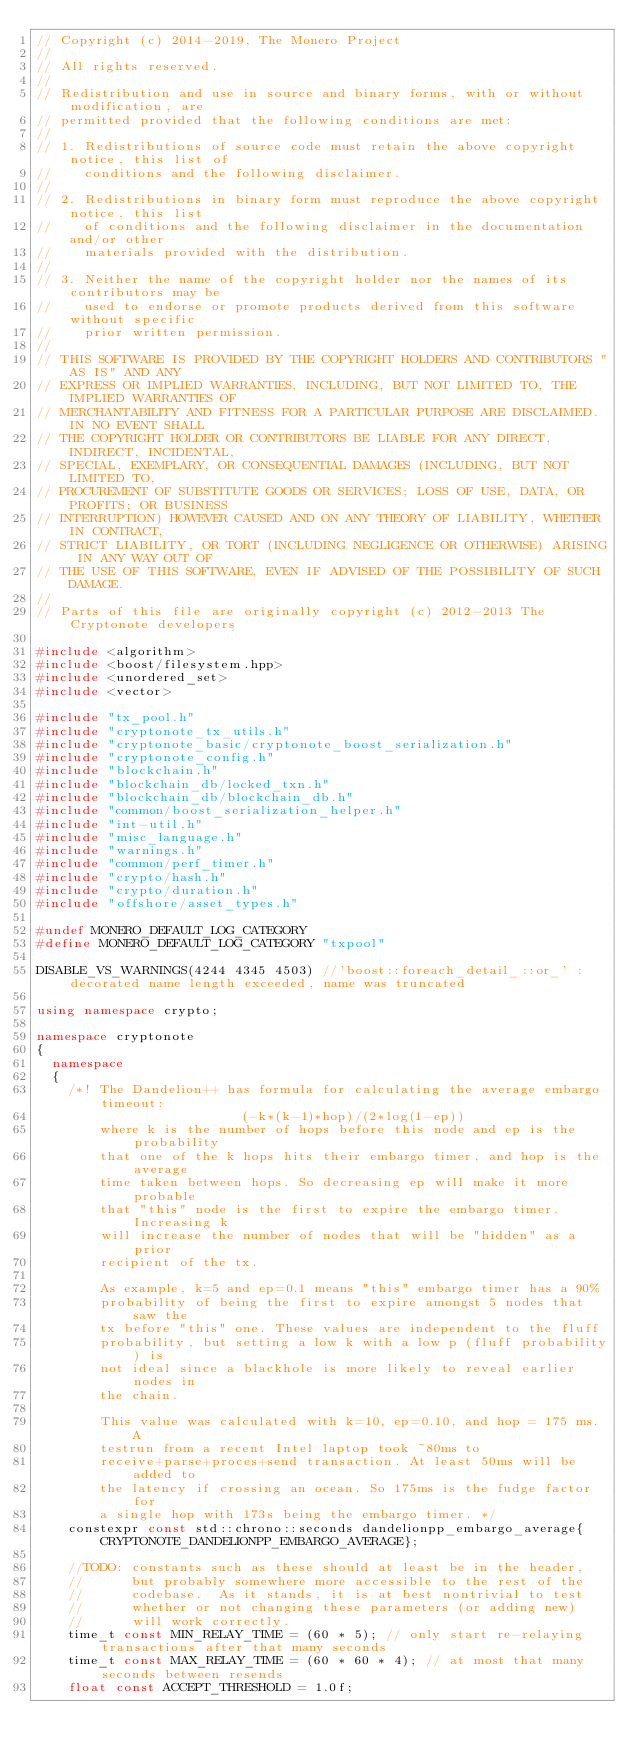Convert code to text. <code><loc_0><loc_0><loc_500><loc_500><_C++_>// Copyright (c) 2014-2019, The Monero Project
//
// All rights reserved.
//
// Redistribution and use in source and binary forms, with or without modification, are
// permitted provided that the following conditions are met:
//
// 1. Redistributions of source code must retain the above copyright notice, this list of
//    conditions and the following disclaimer.
//
// 2. Redistributions in binary form must reproduce the above copyright notice, this list
//    of conditions and the following disclaimer in the documentation and/or other
//    materials provided with the distribution.
//
// 3. Neither the name of the copyright holder nor the names of its contributors may be
//    used to endorse or promote products derived from this software without specific
//    prior written permission.
//
// THIS SOFTWARE IS PROVIDED BY THE COPYRIGHT HOLDERS AND CONTRIBUTORS "AS IS" AND ANY
// EXPRESS OR IMPLIED WARRANTIES, INCLUDING, BUT NOT LIMITED TO, THE IMPLIED WARRANTIES OF
// MERCHANTABILITY AND FITNESS FOR A PARTICULAR PURPOSE ARE DISCLAIMED. IN NO EVENT SHALL
// THE COPYRIGHT HOLDER OR CONTRIBUTORS BE LIABLE FOR ANY DIRECT, INDIRECT, INCIDENTAL,
// SPECIAL, EXEMPLARY, OR CONSEQUENTIAL DAMAGES (INCLUDING, BUT NOT LIMITED TO,
// PROCUREMENT OF SUBSTITUTE GOODS OR SERVICES; LOSS OF USE, DATA, OR PROFITS; OR BUSINESS
// INTERRUPTION) HOWEVER CAUSED AND ON ANY THEORY OF LIABILITY, WHETHER IN CONTRACT,
// STRICT LIABILITY, OR TORT (INCLUDING NEGLIGENCE OR OTHERWISE) ARISING IN ANY WAY OUT OF
// THE USE OF THIS SOFTWARE, EVEN IF ADVISED OF THE POSSIBILITY OF SUCH DAMAGE.
//
// Parts of this file are originally copyright (c) 2012-2013 The Cryptonote developers

#include <algorithm>
#include <boost/filesystem.hpp>
#include <unordered_set>
#include <vector>

#include "tx_pool.h"
#include "cryptonote_tx_utils.h"
#include "cryptonote_basic/cryptonote_boost_serialization.h"
#include "cryptonote_config.h"
#include "blockchain.h"
#include "blockchain_db/locked_txn.h"
#include "blockchain_db/blockchain_db.h"
#include "common/boost_serialization_helper.h"
#include "int-util.h"
#include "misc_language.h"
#include "warnings.h"
#include "common/perf_timer.h"
#include "crypto/hash.h"
#include "crypto/duration.h"
#include "offshore/asset_types.h"

#undef MONERO_DEFAULT_LOG_CATEGORY
#define MONERO_DEFAULT_LOG_CATEGORY "txpool"

DISABLE_VS_WARNINGS(4244 4345 4503) //'boost::foreach_detail_::or_' : decorated name length exceeded, name was truncated

using namespace crypto;

namespace cryptonote
{
  namespace
  {
    /*! The Dandelion++ has formula for calculating the average embargo timeout:
                          (-k*(k-1)*hop)/(2*log(1-ep))
        where k is the number of hops before this node and ep is the probability
        that one of the k hops hits their embargo timer, and hop is the average
        time taken between hops. So decreasing ep will make it more probable
        that "this" node is the first to expire the embargo timer. Increasing k
        will increase the number of nodes that will be "hidden" as a prior
        recipient of the tx.

        As example, k=5 and ep=0.1 means "this" embargo timer has a 90%
        probability of being the first to expire amongst 5 nodes that saw the
        tx before "this" one. These values are independent to the fluff
        probability, but setting a low k with a low p (fluff probability) is
        not ideal since a blackhole is more likely to reveal earlier nodes in
        the chain.

        This value was calculated with k=10, ep=0.10, and hop = 175 ms. A
        testrun from a recent Intel laptop took ~80ms to
        receive+parse+proces+send transaction. At least 50ms will be added to
        the latency if crossing an ocean. So 175ms is the fudge factor for
        a single hop with 173s being the embargo timer. */
    constexpr const std::chrono::seconds dandelionpp_embargo_average{CRYPTONOTE_DANDELIONPP_EMBARGO_AVERAGE};

    //TODO: constants such as these should at least be in the header,
    //      but probably somewhere more accessible to the rest of the
    //      codebase.  As it stands, it is at best nontrivial to test
    //      whether or not changing these parameters (or adding new)
    //      will work correctly.
    time_t const MIN_RELAY_TIME = (60 * 5); // only start re-relaying transactions after that many seconds
    time_t const MAX_RELAY_TIME = (60 * 60 * 4); // at most that many seconds between resends
    float const ACCEPT_THRESHOLD = 1.0f;
</code> 